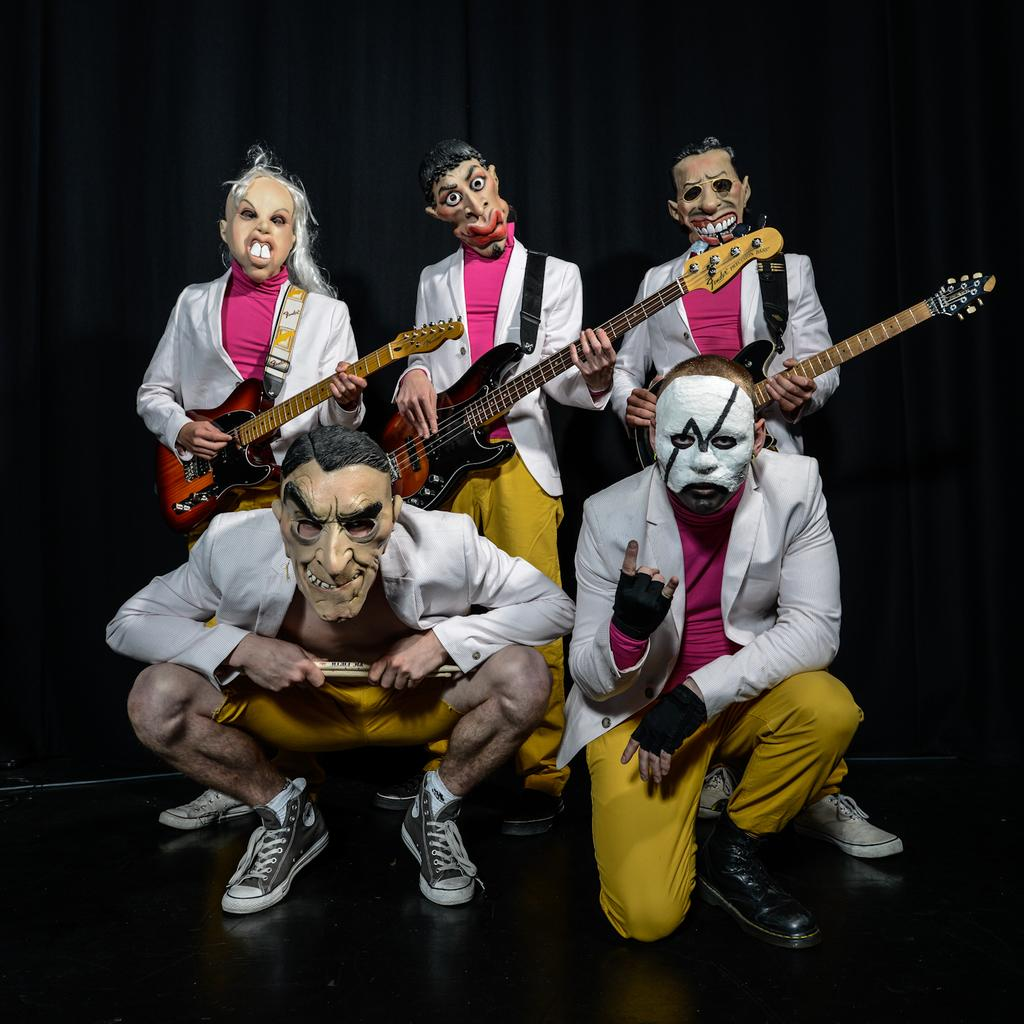How many people are in the image? There are five members in the image. What positions are the members in? Two members are sitting, and three members are standing. What is one of the standing members holding? One of the standing members is holding a guitar. What can be seen in the background of the image? There is a curtain in the background of the image. What type of lace can be seen on the doctor's uniform in the image? There is no doctor or lace present in the image. What mode of transportation is visible in the image? There is no mode of transportation visible in the image. 